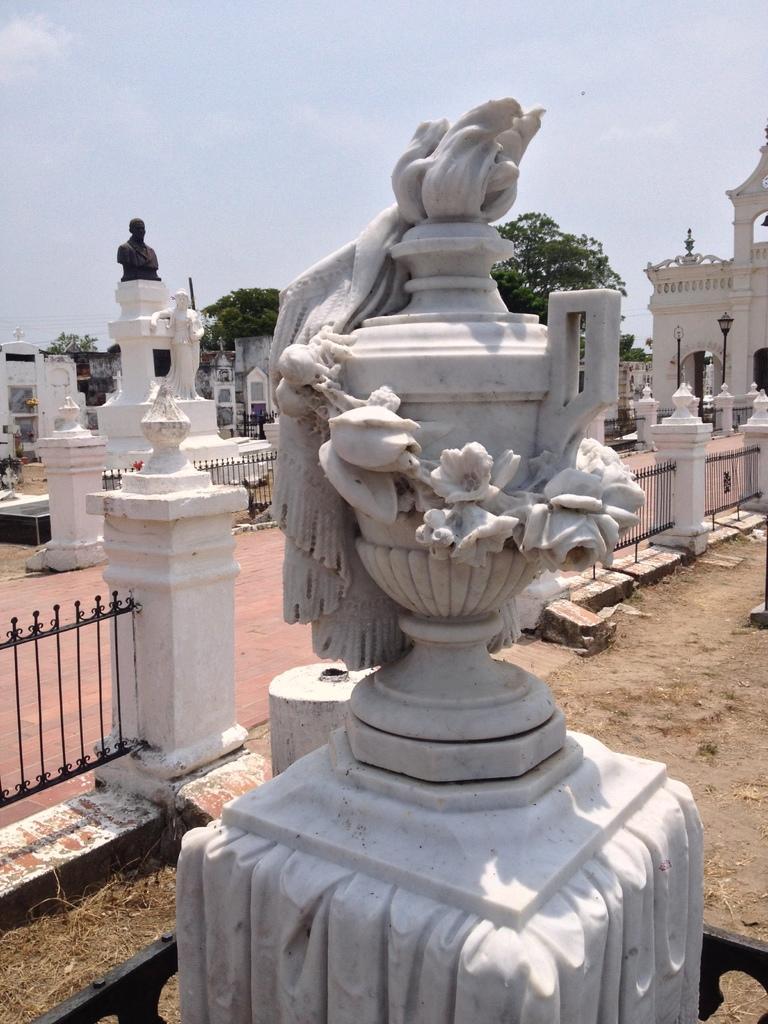Can you describe this image briefly? Here in the front we can see a statue present on the ground over there and behind it we can see a railing present and we can also see other statues present here and there and we can see houses in the far and we can see lamp posts and trees present here and there and we can see clouds in the sky. 